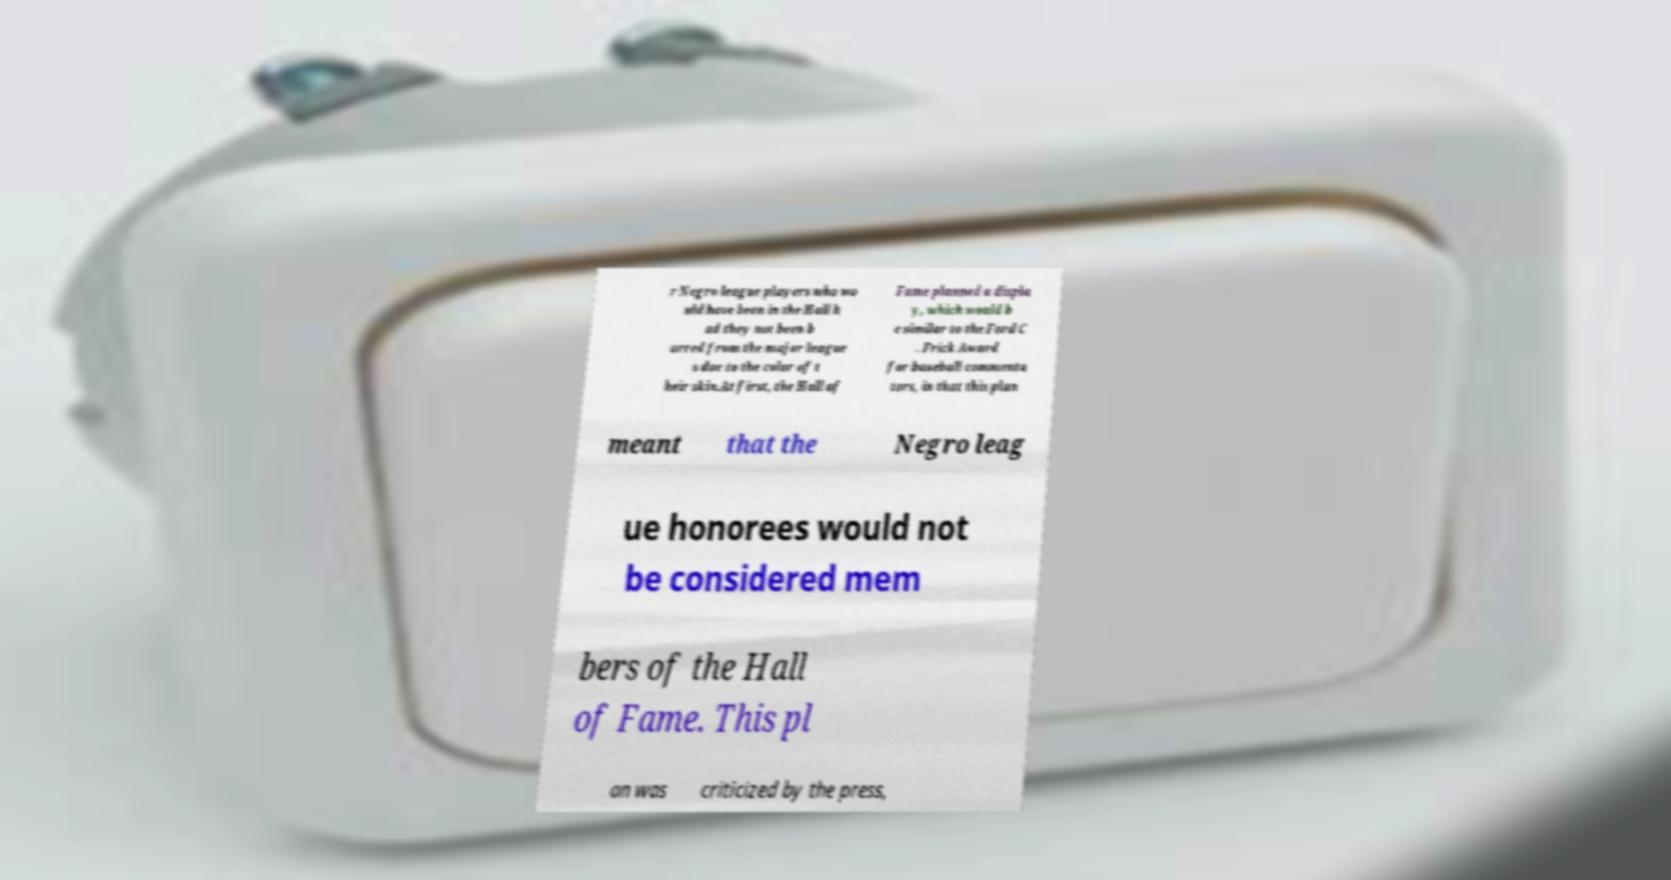Could you assist in decoding the text presented in this image and type it out clearly? r Negro league players who wo uld have been in the Hall h ad they not been b arred from the major league s due to the color of t heir skin.At first, the Hall of Fame planned a displa y, which would b e similar to the Ford C . Frick Award for baseball commenta tors, in that this plan meant that the Negro leag ue honorees would not be considered mem bers of the Hall of Fame. This pl an was criticized by the press, 